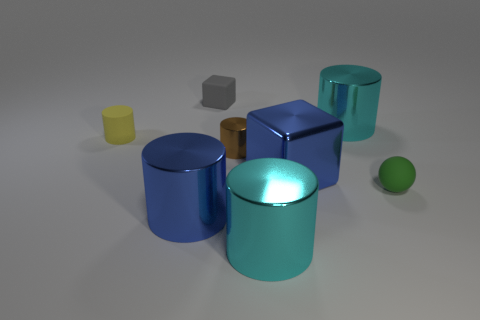Is the number of tiny cylinders that are in front of the yellow matte cylinder the same as the number of small rubber objects? No, the number of tiny cylinders in front of the yellow matte cylinder is not the same as the number of small rubber objects. In the image, we see two small cylinders in front of the yellow matte cylinder, whereas there seems to be only one small rubber object, which is a green sphere. 